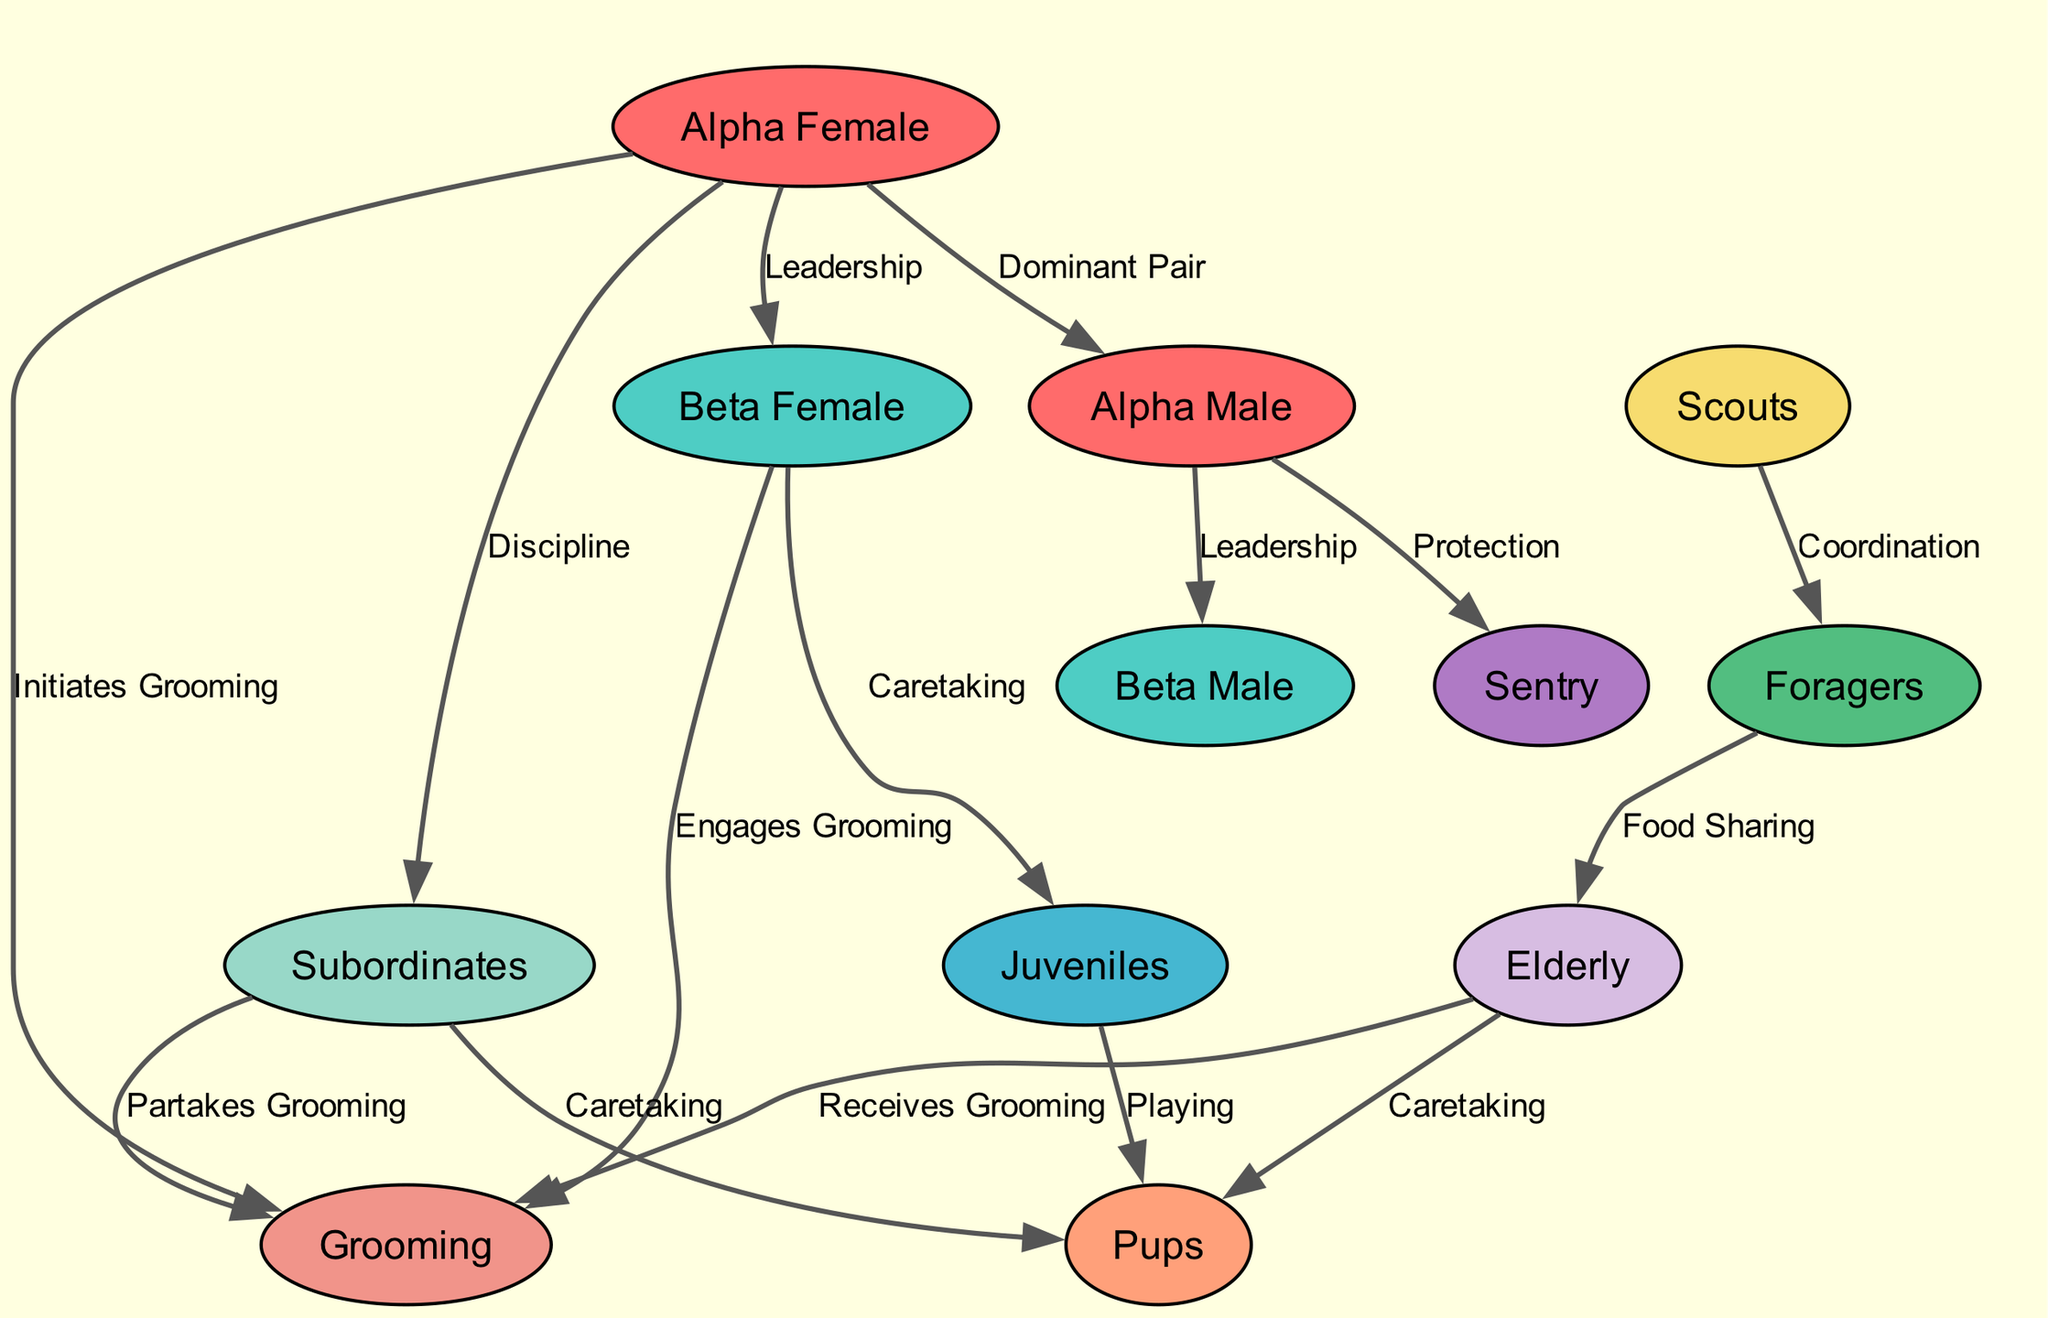What's the total number of nodes in the diagram? By counting all the unique roles represented in the nodes section of the diagram, we find that there are 12 distinct roles contributing to the social hierarchy of the meerkat colony.
Answer: 12 Which role is connected to "alpha male" through a leadership relationship? Looking at the edges in the diagram, I see that "beta male" is the only role directly connected to "alpha male" with the label "Leadership," indicating they both share certain responsibilities under the same leadership structure.
Answer: Beta Male How many different interactions are initiated by the "alpha female"? The diagram highlights that the "alpha female" interacts with four distinct roles: initiating grooming, leading discipline, and having a strong presence in the hierarchy. After examining the edges, we can see that there are three distinct interactions flowing from "alpha female."
Answer: 3 Which role directly plays a part in the 'Caretaking' relationship besides "beta female"? In the edges of the diagram, two roles are connected to a 'Caretaking' relationship: "beta female" and "subordinates." Since both roles fulfill caretaking roles for different groups of meerkats, this question prompts us to consider them both.
Answer: Subordinates What is the relationship between "foragers" and "elderly"? I can analyze the edges in the diagram where "foragers" are linked to "elderly" with the label "Food Sharing." This particular relationship delineates a mutual assistance role in terms of food distribution in the meerkat colony.
Answer: Food Sharing Which role is responsible for protection in the diagram? By inspecting the edges associated with the "alpha male," I identify that he is linked to the "sentry" with the label "Protection," indicating his role in safeguarding the group.
Answer: Sentry How are "scouts" related to "foragers"? The relationship is laid out directly in the edges, showing that "scouts" and "foragers" are interconnected through the label "Coordination," illustrating their collaborative roles in resource gathering and safety.
Answer: Coordination What interaction type does the "elderly" engage in according to the diagram? Reviewing the edges linked to "elderly," I see that they both connect to 'Caretaking' relationships, as well as being recipients of grooming actions. This indicates their important role in the social structure as both caregivers and receivers.
Answer: Receives Grooming Which two roles form the 'Dominant Pair'? Upon examining the edges of the diagram, it clearly indicates that the 'Dominant Pair' consists of "alpha female" and "alpha male," mapping out their leadership dynamic within the meerkat colony.
Answer: Alpha Female and Alpha Male 